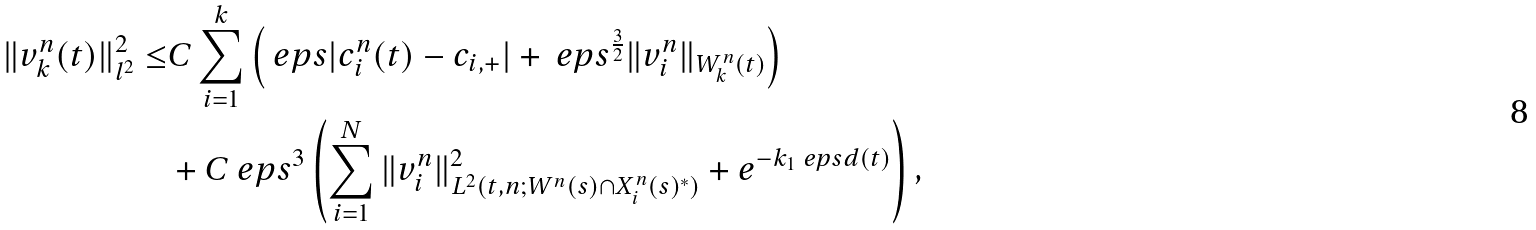<formula> <loc_0><loc_0><loc_500><loc_500>\| v _ { k } ^ { n } ( t ) \| _ { l ^ { 2 } } ^ { 2 } \leq & C \sum _ { i = 1 } ^ { k } \left ( \ e p s | c _ { i } ^ { n } ( t ) - c _ { i , + } | + \ e p s ^ { \frac { 3 } { 2 } } \| v _ { i } ^ { n } \| _ { W _ { k } ^ { n } ( t ) } \right ) \\ & + C \ e p s ^ { 3 } \left ( \sum _ { i = 1 } ^ { N } \| v _ { i } ^ { n } \| _ { L ^ { 2 } ( t , n ; W ^ { n } ( s ) \cap X _ { i } ^ { n } ( s ) ^ { * } ) } ^ { 2 } + e ^ { - k _ { 1 } \ e p s d ( t ) } \right ) ,</formula> 